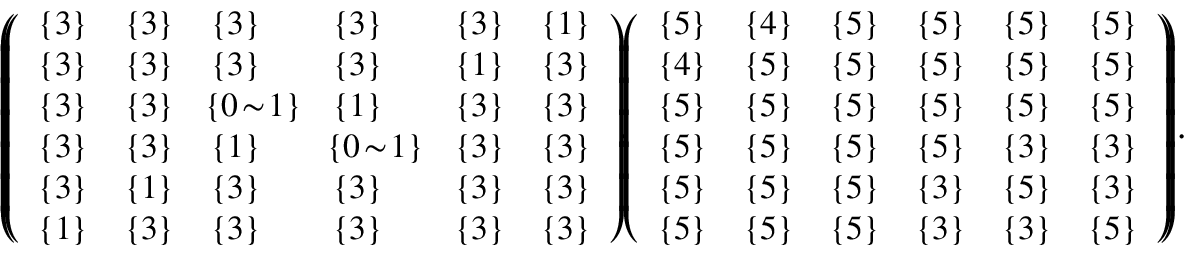<formula> <loc_0><loc_0><loc_500><loc_500>\begin{array} { r l } & { \left ( \, \left ( \begin{array} { l l l l l l } { \{ 3 \} } & { \{ 3 \} } & { \{ 3 \} } & { \{ 3 \} } & { \{ 3 \} } & { \{ 1 \} } \\ { \{ 3 \} } & { \{ 3 \} } & { \{ 3 \} } & { \{ 3 \} } & { \{ 1 \} } & { \{ 3 \} } \\ { \{ 3 \} } & { \{ 3 \} } & { \, \{ 0 \, \sim \, 1 \} \, } & { \{ 1 \} } & { \{ 3 \} } & { \{ 3 \} } \\ { \{ 3 \} } & { \{ 3 \} } & { \{ 1 \} } & { \, \{ 0 \, \sim \, 1 \} \, } & { \{ 3 \} } & { \{ 3 \} } \\ { \{ 3 \} } & { \{ 1 \} } & { \{ 3 \} } & { \{ 3 \} } & { \{ 3 \} } & { \{ 3 \} } \\ { \{ 1 \} } & { \{ 3 \} } & { \{ 3 \} } & { \{ 3 \} } & { \{ 3 \} } & { \{ 3 \} } \end{array} \right ) \, , \, \left ( \begin{array} { l l l l l l } { \{ 5 \} } & { \{ 4 \} } & { \{ 5 \} } & { \{ 5 \} } & { \{ 5 \} } & { \{ 5 \} } \\ { \{ 4 \} } & { \{ 5 \} } & { \{ 5 \} } & { \{ 5 \} } & { \{ 5 \} } & { \{ 5 \} } \\ { \{ 5 \} } & { \{ 5 \} } & { \{ 5 \} } & { \{ 5 \} } & { \{ 5 \} } & { \{ 5 \} } \\ { \{ 5 \} } & { \{ 5 \} } & { \{ 5 \} } & { \{ 5 \} } & { \{ 3 \} } & { \{ 3 \} } \\ { \{ 5 \} } & { \{ 5 \} } & { \{ 5 \} } & { \{ 3 \} } & { \{ 5 \} } & { \{ 3 \} } \\ { \{ 5 \} } & { \{ 5 \} } & { \{ 5 \} } & { \{ 3 \} } & { \{ 3 \} } & { \{ 5 \} } \end{array} \right ) \, \right ) \, . } \end{array}</formula> 